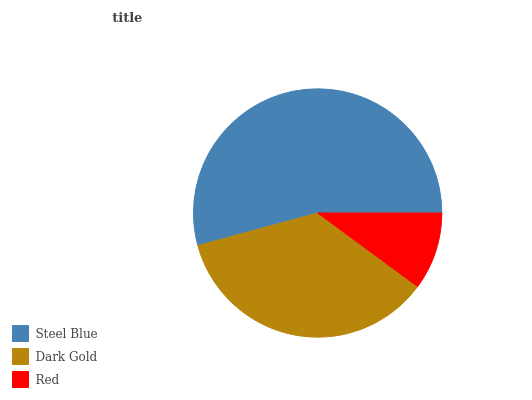Is Red the minimum?
Answer yes or no. Yes. Is Steel Blue the maximum?
Answer yes or no. Yes. Is Dark Gold the minimum?
Answer yes or no. No. Is Dark Gold the maximum?
Answer yes or no. No. Is Steel Blue greater than Dark Gold?
Answer yes or no. Yes. Is Dark Gold less than Steel Blue?
Answer yes or no. Yes. Is Dark Gold greater than Steel Blue?
Answer yes or no. No. Is Steel Blue less than Dark Gold?
Answer yes or no. No. Is Dark Gold the high median?
Answer yes or no. Yes. Is Dark Gold the low median?
Answer yes or no. Yes. Is Steel Blue the high median?
Answer yes or no. No. Is Red the low median?
Answer yes or no. No. 